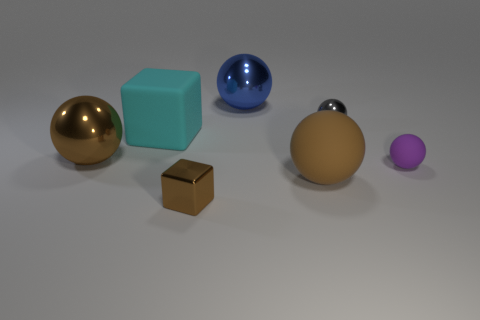How many metal spheres are the same color as the small metallic block?
Your response must be concise. 1. Is the size of the purple sphere the same as the cyan block?
Offer a very short reply. No. There is a small metal block; how many metallic blocks are behind it?
Ensure brevity in your answer.  0. What number of things are tiny shiny things that are on the left side of the tiny metallic sphere or big blue balls?
Offer a very short reply. 2. Is the number of big blue metal objects that are behind the brown metal cube greater than the number of large cyan things to the right of the cyan matte cube?
Give a very brief answer. Yes. What is the size of the other ball that is the same color as the big matte sphere?
Provide a succinct answer. Large. There is a blue shiny ball; is its size the same as the matte thing left of the tiny metallic cube?
Keep it short and to the point. Yes. How many cylinders are shiny things or tiny brown objects?
Offer a very short reply. 0. What is the size of the brown sphere that is made of the same material as the gray object?
Provide a succinct answer. Large. Is the size of the sphere behind the gray ball the same as the sphere to the right of the gray shiny object?
Ensure brevity in your answer.  No. 